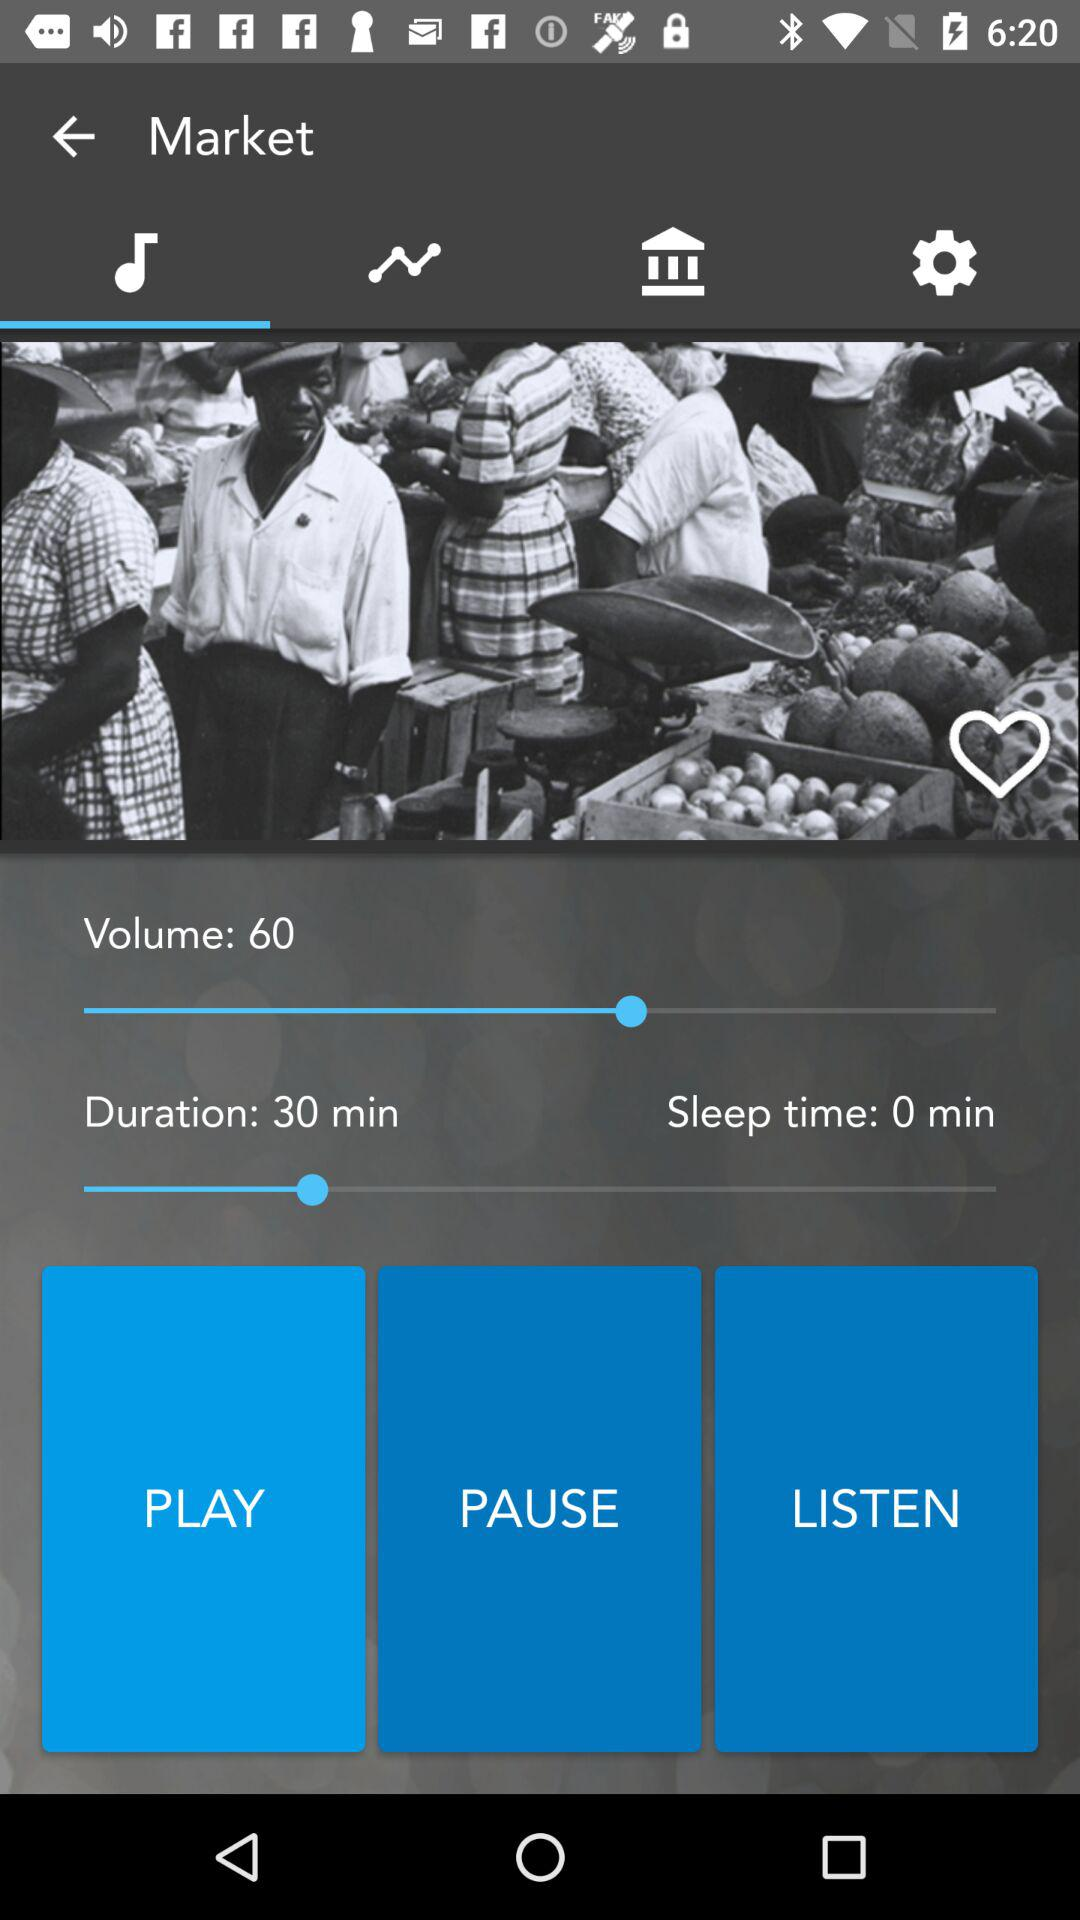What is the duration? The duration is 30 minutes. 